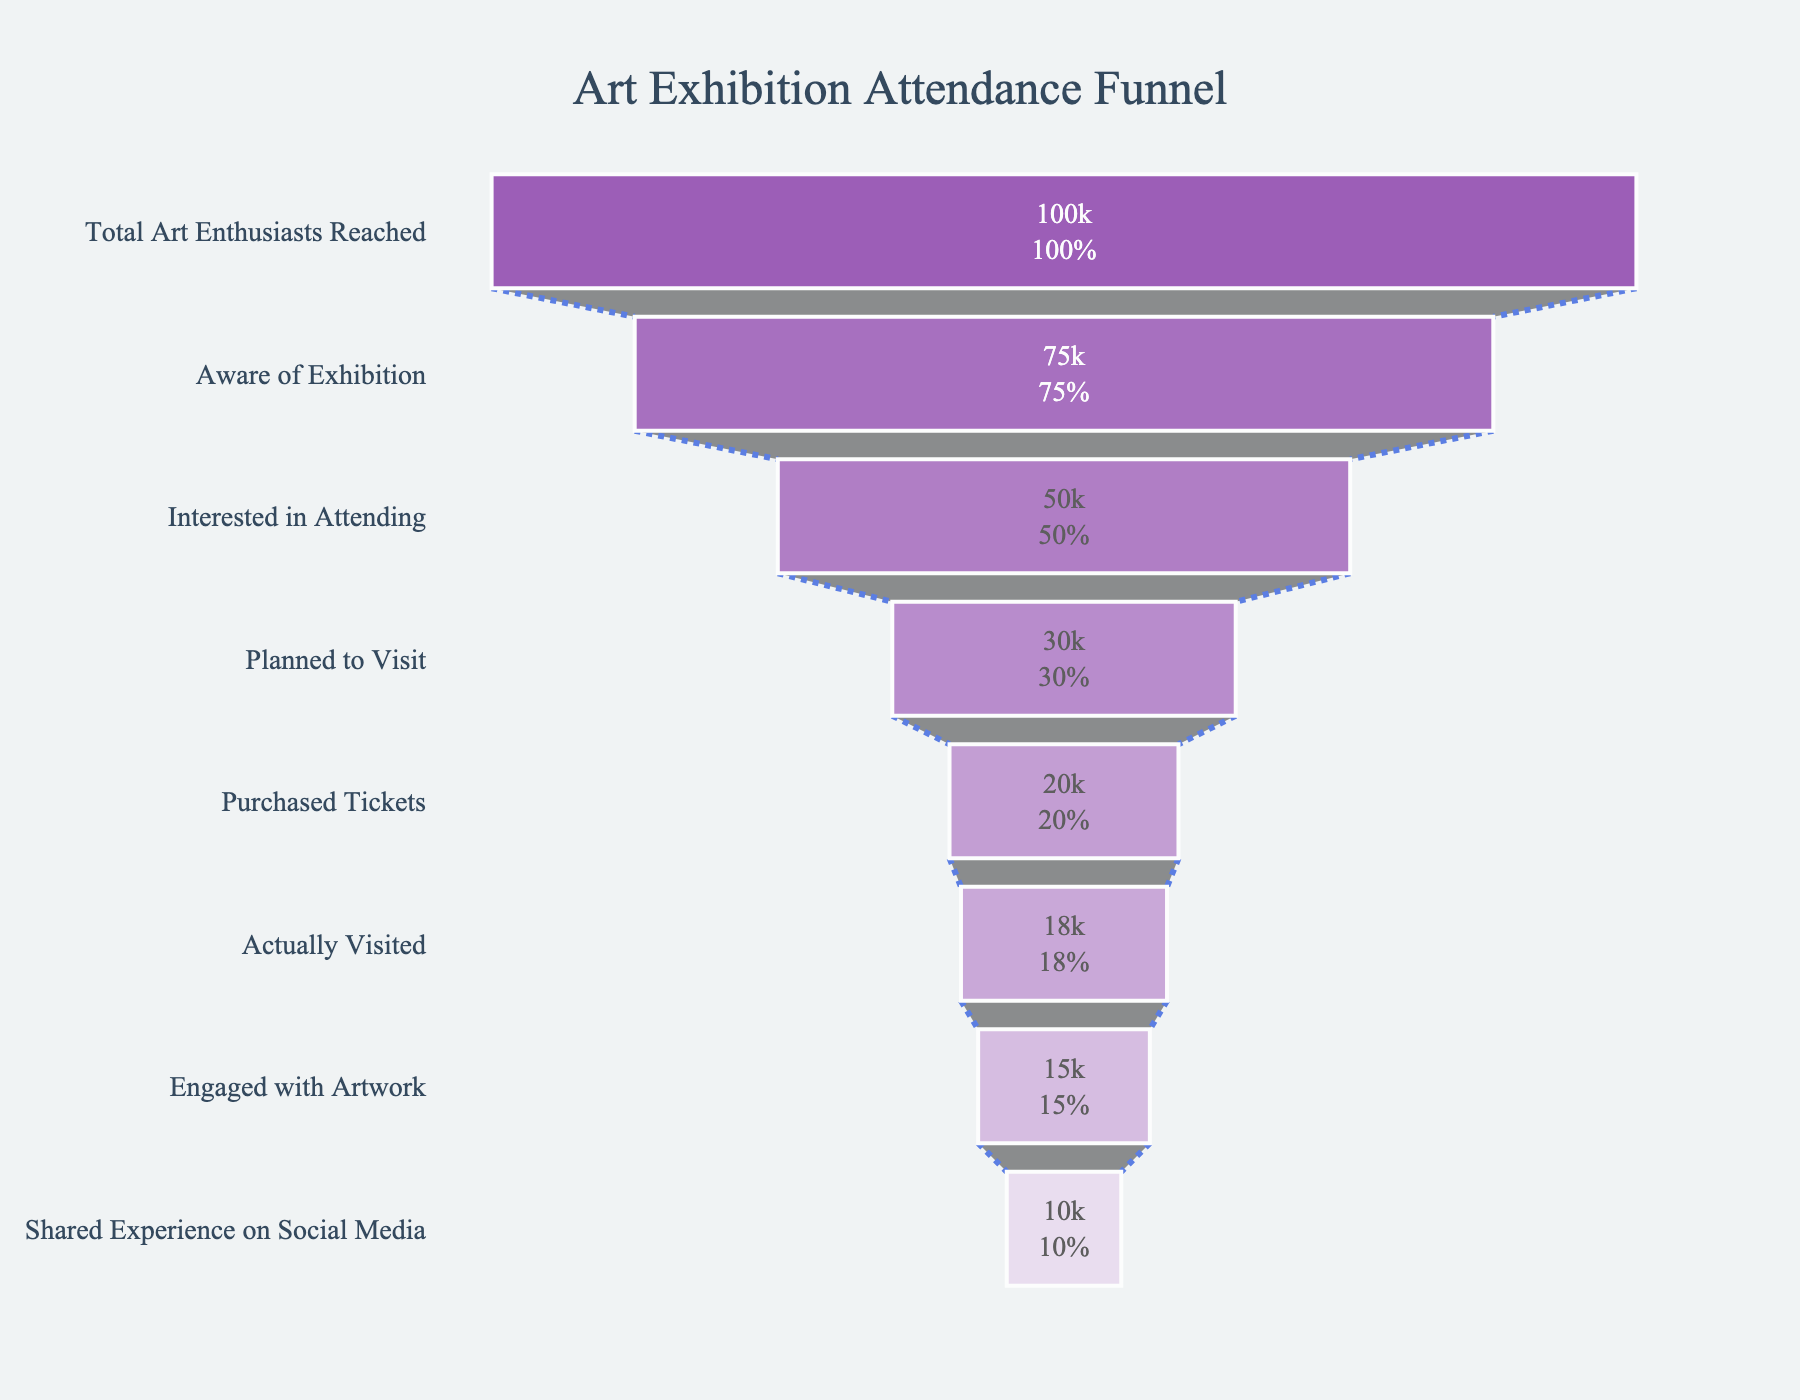What's the title of the figure? The title of the figure is prominently displayed at the top of the plot.
Answer: Art Exhibition Attendance Funnel How many people planned to visit the exhibition? The funnel chart shows the number under the "Planned to Visit" stage.
Answer: 30,000 How does the number of people who actually visited the exhibition compare to those who planned to visit? The chart shows 30,000 people planned to visit, but 18,000 actually did. The difference, calculated by subtraction, is 12,000.
Answer: 12,000 less What percentage of people who were aware of the exhibition became interested in attending? The funnel chart provides both the numbers and the percentages between stages. There are 75,000 people aware of the exhibition, and 50,000 became interested. This percentage is shown directly inside the bar.
Answer: 66.67% Of the total art enthusiasts reached, what percentage actually visited the exhibition? The number of art enthusiasts reached is 100,000, and those who visited is 18,000. The percentage is calculated by (18,000 / 100,000) * 100 = 18%.
Answer: 18% Which stage shows the largest drop-off in number of people? The drop-off can be calculated by finding the difference between each consecutive stage. The largest difference is between "Interested in Attending" (50,000) and "Planned to Visit" (30,000).
Answer: From "Interested in Attending" to "Planned to Visit" How many people engaged with the artwork after actually visiting? The number of people who engaged with the artwork is directly given under the "Engaged with Artwork" stage in the chart.
Answer: 15,000 What fraction of ticket purchasers actually visited the exhibition? There are 20,000 people who purchased tickets and 18,000 who visited. The fraction is 18,000 / 20,000, which simplifies to 9/10.
Answer: 9/10 What is the number of people who shared their experience on social media as a percentage of those who engaged with the artwork? There are 15,000 who engaged with the artwork and 10,000 who shared their experience. The percentage is calculated as (10,000 / 15,000) * 100 = 66.67%.
Answer: 66.67% Which stage has the lowest conversion rate, and what is it? Conversion rate can be calculated for each stage as a percentage comparison with the previous stage. The lowest conversion rate is from "Interested in Attending" (50,000) to "Planned to Visit" (30,000), which is (30,000 / 50,000) * 100 = 60%.
Answer: "Planned to Visit" at 60% 